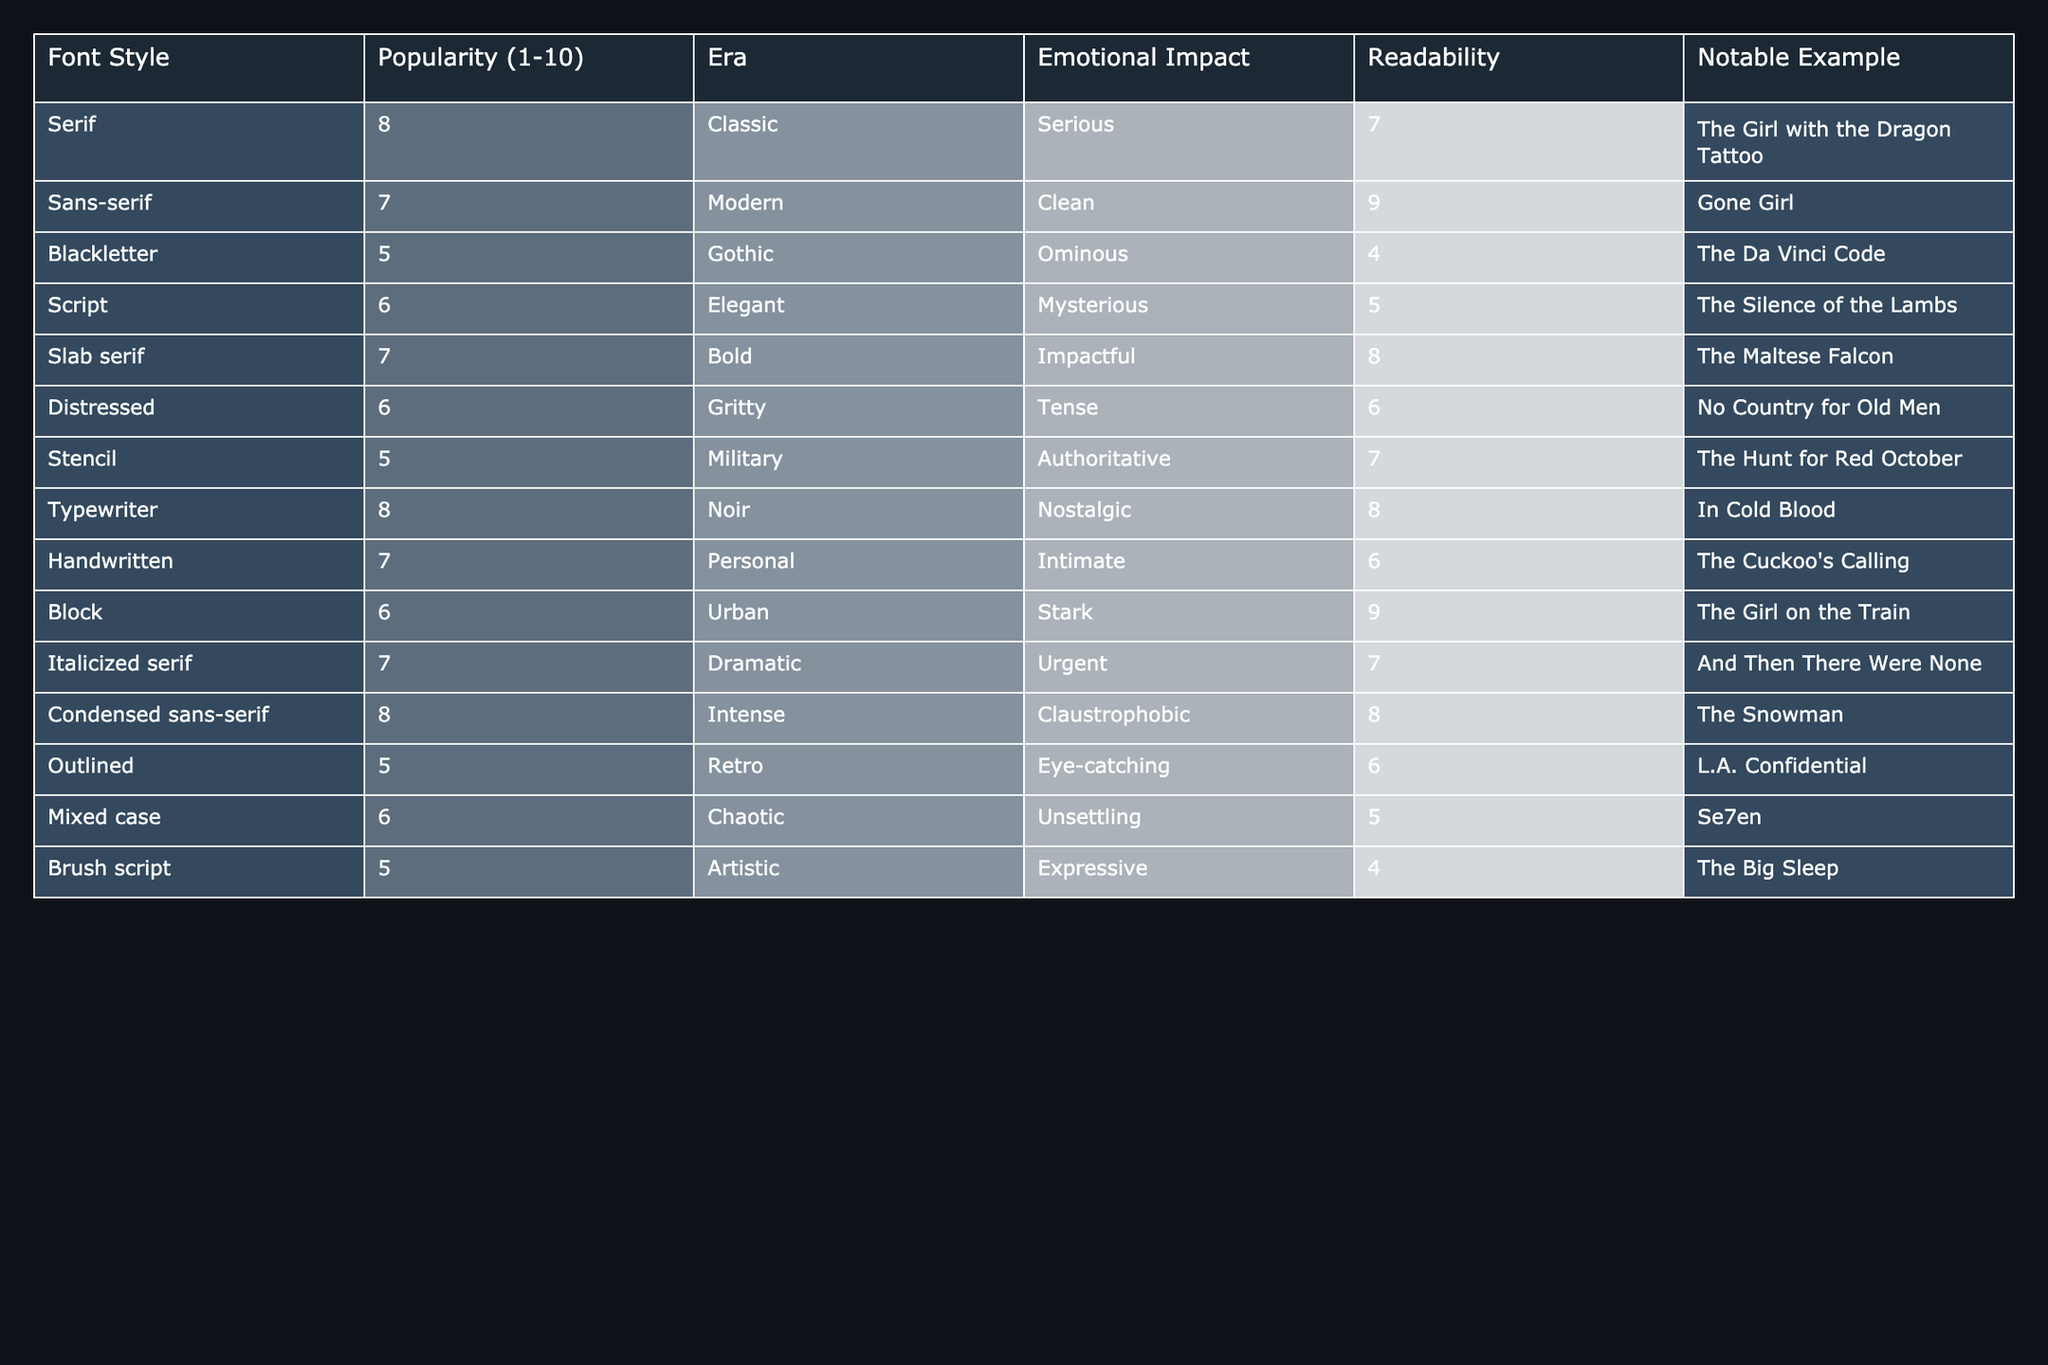What is the most popular font style according to the table? The most popular font style is indicated by the highest score in the "Popularity" column. By looking through the table, "Serif" has a popularity score of 8, which is the highest.
Answer: Serif Which font styles have a readability score of 9? To find the font styles with a readability score of 9, we can inspect the "Readability" column for the value of 9. In the table, "Sans-serif" and "Block" both have a readability score of 9.
Answer: Sans-serif, Block What is the emotional impact of the "Condensed sans-serif" font style? The emotional impact of the "Condensed sans-serif" font style is found in the corresponding row under the "Emotional Impact" column. It states "Claustrophobic".
Answer: Claustrophobic Is the emotional impact of "Blackletter" more serious than that of "Script"? We evaluate the emotional impacts as denoted in the table. "Blackletter" has an emotional impact of "Ominous," while "Script" has "Mysterious." Since "Ominous" generally conveys a more serious tone than "Mysterious," the statement is true.
Answer: Yes What is the average popularity score of all the font styles listed? To find the average popularity score, we sum the scores in the "Popularity" column: 8 + 7 + 5 + 6 + 7 + 6 + 5 + 8 + 7 + 6 + 7 + 8 + 5 + 5 = 83. There are 14 font styles, so the average is 83 / 14, which equals approximately 5.93.
Answer: 5.93 Which font style has the lowest emotional impact score, and what is that score? We need to look at the "Emotional Impact" column and identify the style with the lowest impact. "Script" has an emotional impact of "Mysterious," while all other styles have more dramatic impacts, but we focus on the numeric score which suggests a lower emotional value is "4" for "Brush script."
Answer: Brush script, 4 Does any font style combine modern aesthetics with high emotional impacts? We observe the font styles with both a modern classification (like "Sans-serif" and "Condensed sans-serif") and an emotional impact of at least 7. "Sans-serif" is modern and has a clean impact of 7, while "Condensed sans-serif" has a claustrophobic impact of 8. Therefore, there are two fitting styles.
Answer: Yes What percentage of the font styles have a readability score of 6 or higher? To calculate this, we first count the number of font styles with a readability score of 6 or higher. The valid scores are for "Sans-serif," "Slab serif," "Typewriter," "Condensed sans-serif," and "Block," giving us 10 out of 14 styles. Thus, the percentage is (10 / 14) * 100 = 71.43%.
Answer: 71.43% 